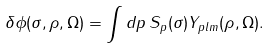Convert formula to latex. <formula><loc_0><loc_0><loc_500><loc_500>\delta \phi ( \sigma , \rho , \Omega ) = \int d p \, S _ { p } ( \sigma ) Y _ { p l m } ( \rho , \Omega ) .</formula> 